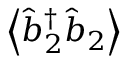Convert formula to latex. <formula><loc_0><loc_0><loc_500><loc_500>\left \langle \hat { b } _ { 2 } ^ { \dagger } \hat { b } _ { 2 } \right \rangle</formula> 